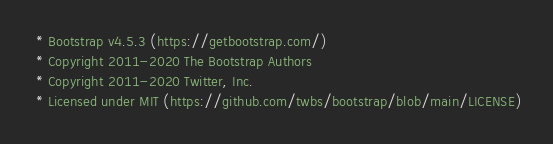Convert code to text. <code><loc_0><loc_0><loc_500><loc_500><_CSS_> * Bootstrap v4.5.3 (https://getbootstrap.com/)
 * Copyright 2011-2020 The Bootstrap Authors
 * Copyright 2011-2020 Twitter, Inc.
 * Licensed under MIT (https://github.com/twbs/bootstrap/blob/main/LICENSE)</code> 